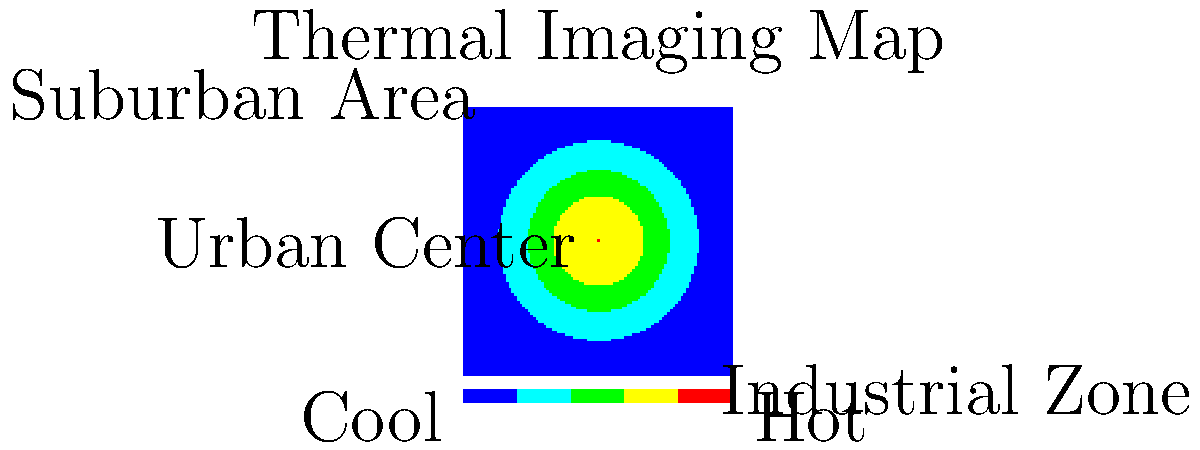Based on the thermal imaging map provided, which area of the city appears to be most affected by the urban heat island effect, and what strategies could be implemented to mitigate this effect in urban planning? To answer this question, let's analyze the thermal imaging map step-by-step:

1. Interpretation of the map:
   - The color gradient ranges from blue (cool) to red (hot).
   - The center of the map shows the highest temperatures (red).
   - The outer areas of the map show cooler temperatures (blue and green).

2. Identifying the most affected area:
   - The Urban Center, located at the center of the map, displays the highest temperatures (red).
   - This indicates that the Urban Center is most affected by the urban heat island effect.

3. Causes of urban heat island effect:
   - High concentration of buildings and paved surfaces
   - Lack of vegetation and green spaces
   - Heat-absorbing materials used in construction
   - Anthropogenic heat sources (e.g., air conditioning, vehicles)

4. Strategies to mitigate the urban heat island effect:
   a) Increase green spaces:
      - Plant trees and create parks to provide shade and evaporative cooling
      - Implement green roofs and vertical gardens on buildings

   b) Use cool materials:
      - Utilize reflective or light-colored materials for roofs and pavements
      - Implement cool pavement technologies

   c) Improve urban design:
      - Create open spaces and corridors for air circulation
      - Design buildings to maximize natural ventilation

   d) Reduce anthropogenic heat:
      - Promote energy-efficient buildings and appliances
      - Encourage use of public transportation and non-motorized transport

   e) Water features:
      - Incorporate fountains, ponds, and other water bodies to provide evaporative cooling

5. Implementation in urban planning:
   - Integrate these strategies into zoning regulations and building codes
   - Develop incentives for developers to incorporate heat-mitigation measures
   - Create a comprehensive urban heat management plan
   - Monitor and evaluate the effectiveness of implemented strategies using regular thermal imaging

By implementing these strategies, urban planners can work to reduce the urban heat island effect, particularly in the most affected Urban Center area, leading to improved thermal comfort, energy efficiency, and overall quality of life for city residents.
Answer: Urban Center; implement green spaces, cool materials, improved urban design, reduce anthropogenic heat, and incorporate water features. 